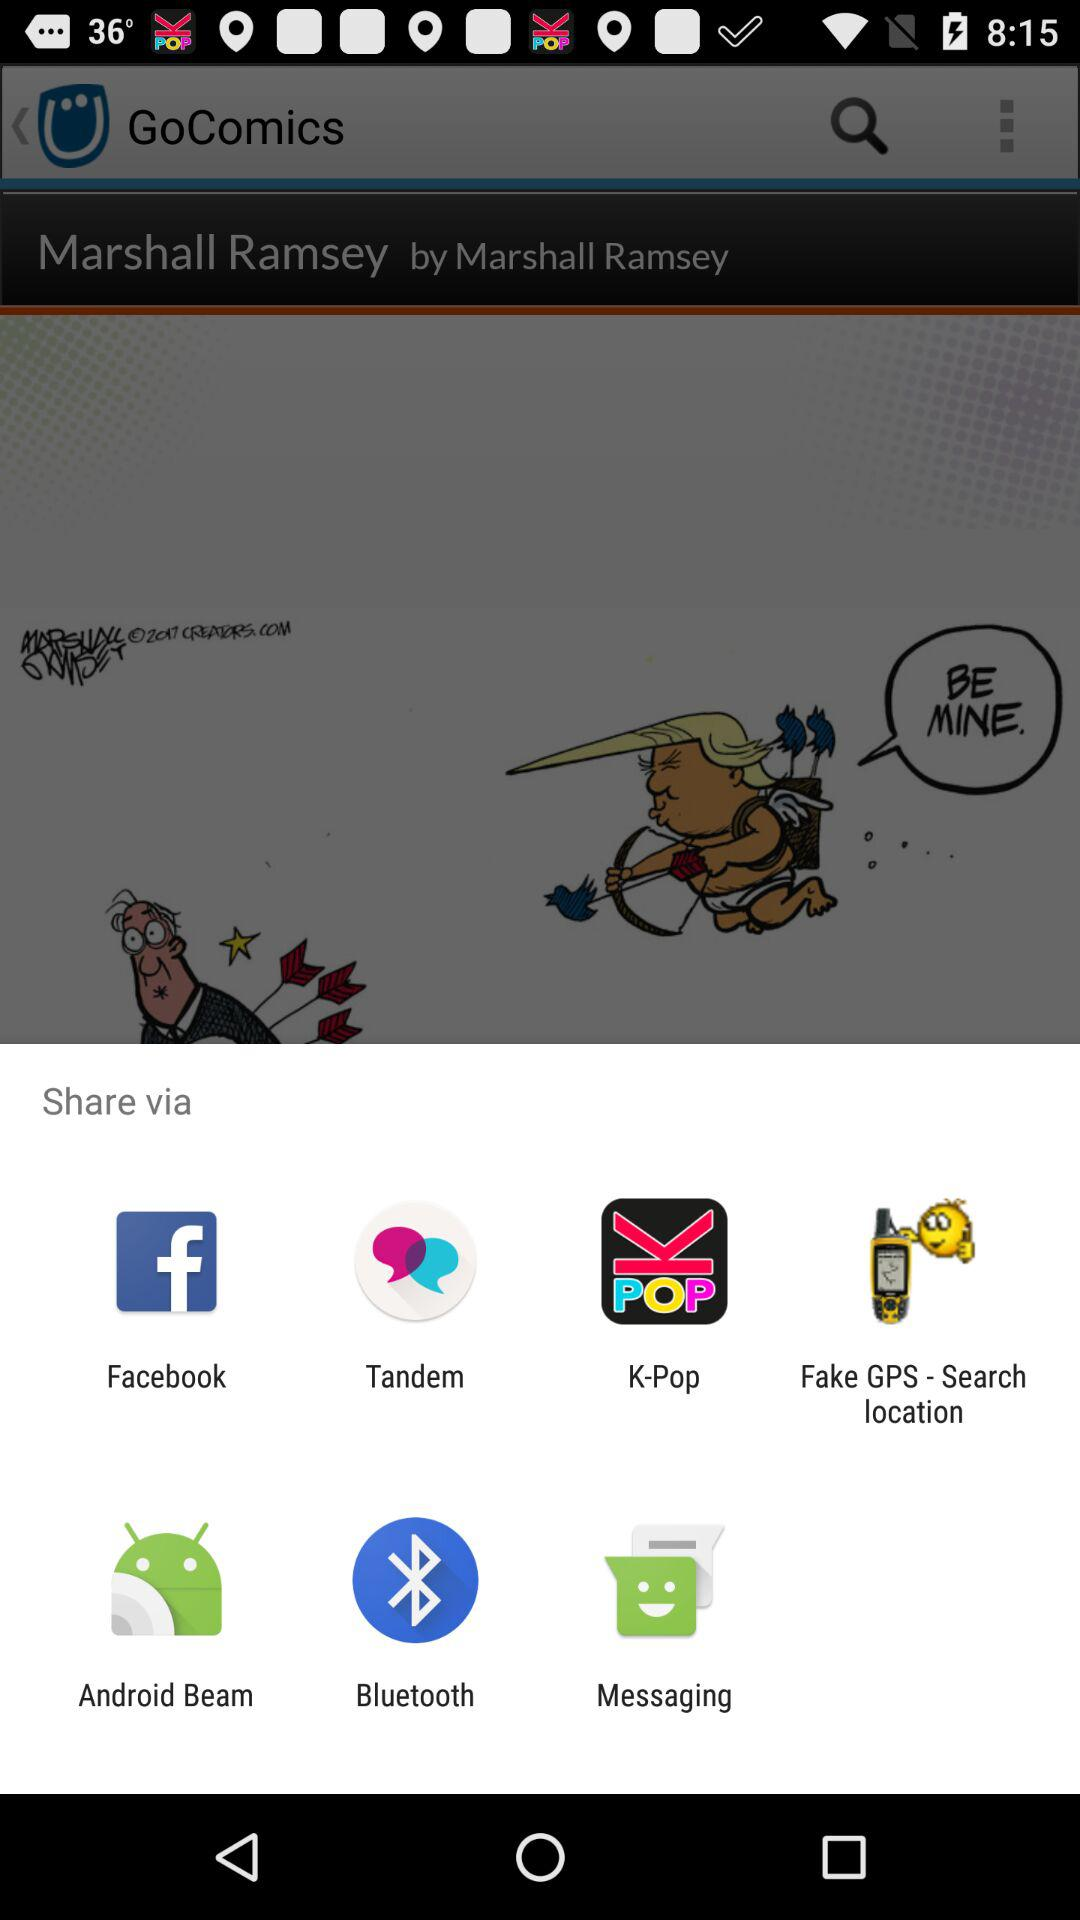Which applications can be used to share?
Answer the question using a single word or phrase. The applications that can be used to share are "Facebook", "Tandem", "K-Pop", "Fake GPS - Search location", "Android Beam", "Bluetooth" and "Messaging" 